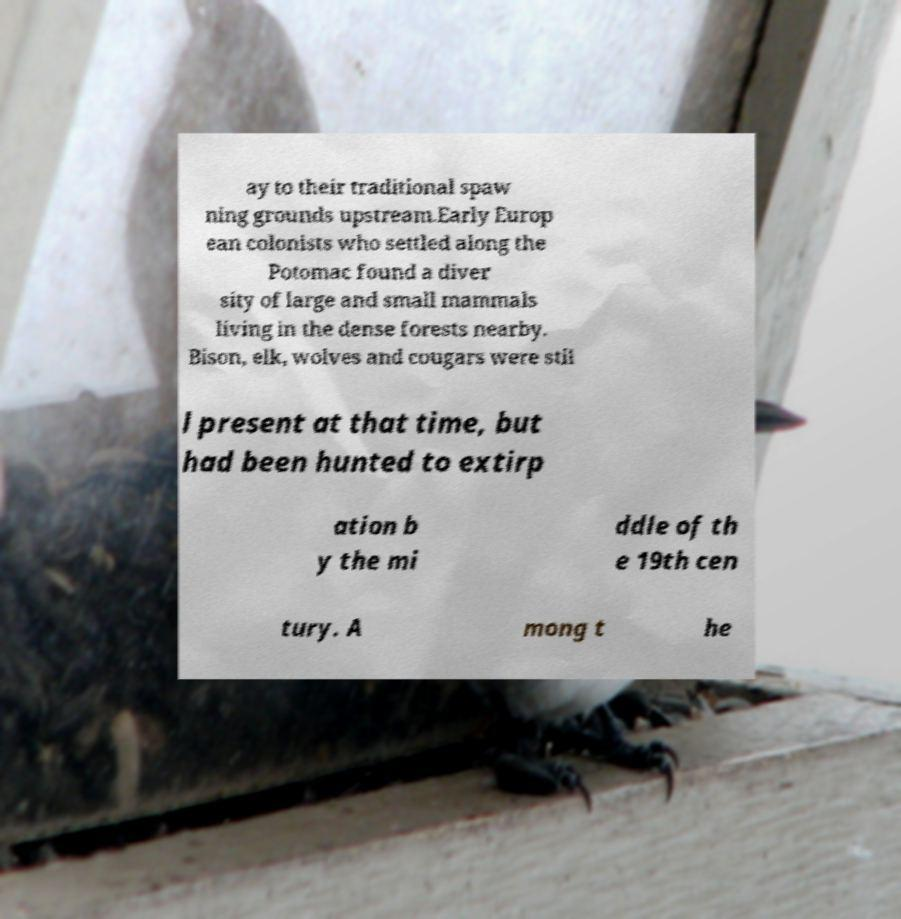There's text embedded in this image that I need extracted. Can you transcribe it verbatim? ay to their traditional spaw ning grounds upstream.Early Europ ean colonists who settled along the Potomac found a diver sity of large and small mammals living in the dense forests nearby. Bison, elk, wolves and cougars were stil l present at that time, but had been hunted to extirp ation b y the mi ddle of th e 19th cen tury. A mong t he 